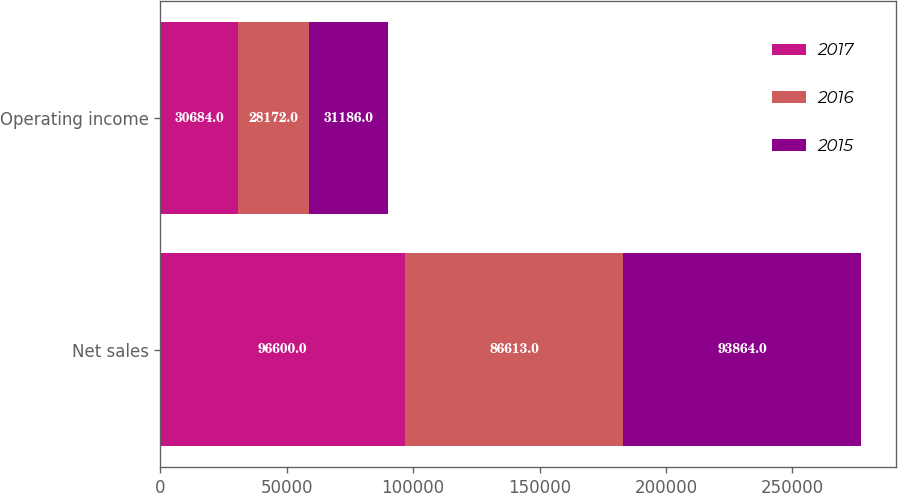Convert chart to OTSL. <chart><loc_0><loc_0><loc_500><loc_500><stacked_bar_chart><ecel><fcel>Net sales<fcel>Operating income<nl><fcel>2017<fcel>96600<fcel>30684<nl><fcel>2016<fcel>86613<fcel>28172<nl><fcel>2015<fcel>93864<fcel>31186<nl></chart> 